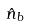<formula> <loc_0><loc_0><loc_500><loc_500>\hat { n } _ { b }</formula> 